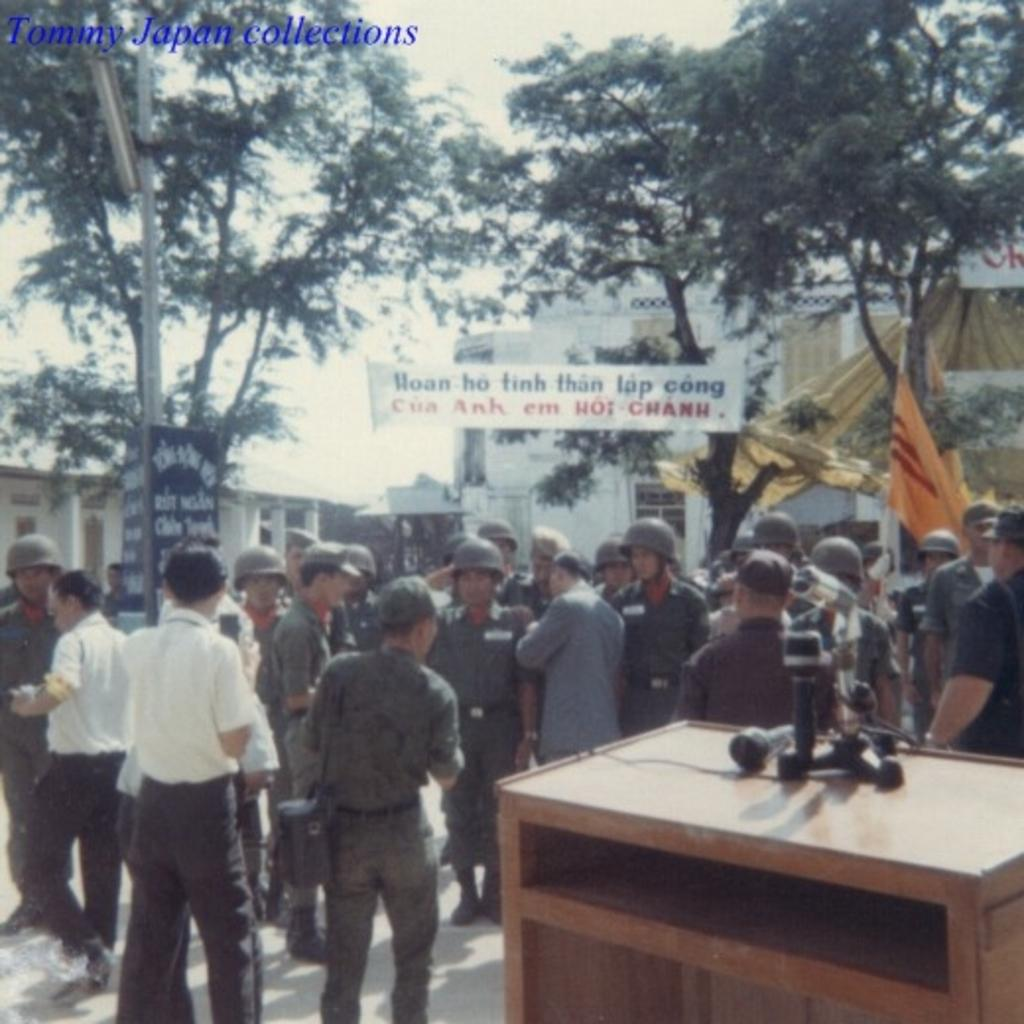How many people are in the group visible in the image? There is a group of people in the image, but the exact number cannot be determined from the provided facts. What is on the table in the image? There is a table in the image, but the facts do not specify what is on it. What does the banner in the image say or represent? The facts do not provide any information about the content or purpose of the banner. What type of buildings can be seen in the image? The facts do not specify the type or style of the buildings visible in the image. What type of trees are in the image? The facts do not specify the type of trees visible in the image. What is the weather like in the image? The sky is clear in the image, which suggests good weather or a clear day. What type of juice is being served in the image? There is no mention of juice in the provided facts, so it cannot be determined from the image. What type of pickle is on the table in the image? There is no mention of pickles in the provided facts, so it cannot be determined from the image. 